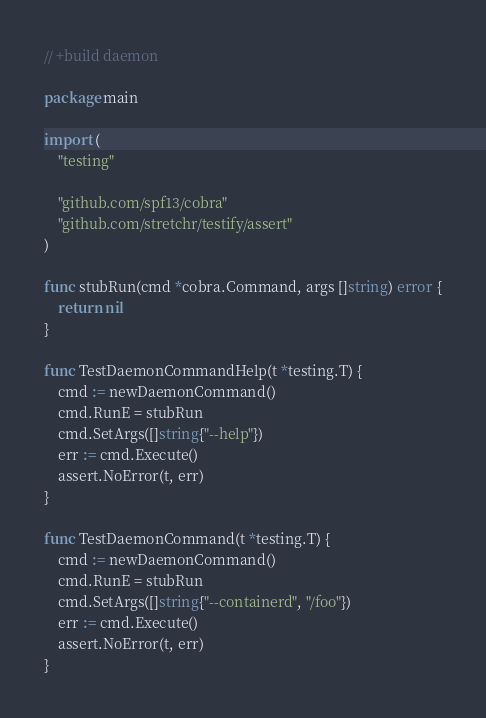<code> <loc_0><loc_0><loc_500><loc_500><_Go_>// +build daemon

package main

import (
	"testing"

	"github.com/spf13/cobra"
	"github.com/stretchr/testify/assert"
)

func stubRun(cmd *cobra.Command, args []string) error {
	return nil
}

func TestDaemonCommandHelp(t *testing.T) {
	cmd := newDaemonCommand()
	cmd.RunE = stubRun
	cmd.SetArgs([]string{"--help"})
	err := cmd.Execute()
	assert.NoError(t, err)
}

func TestDaemonCommand(t *testing.T) {
	cmd := newDaemonCommand()
	cmd.RunE = stubRun
	cmd.SetArgs([]string{"--containerd", "/foo"})
	err := cmd.Execute()
	assert.NoError(t, err)
}
</code> 